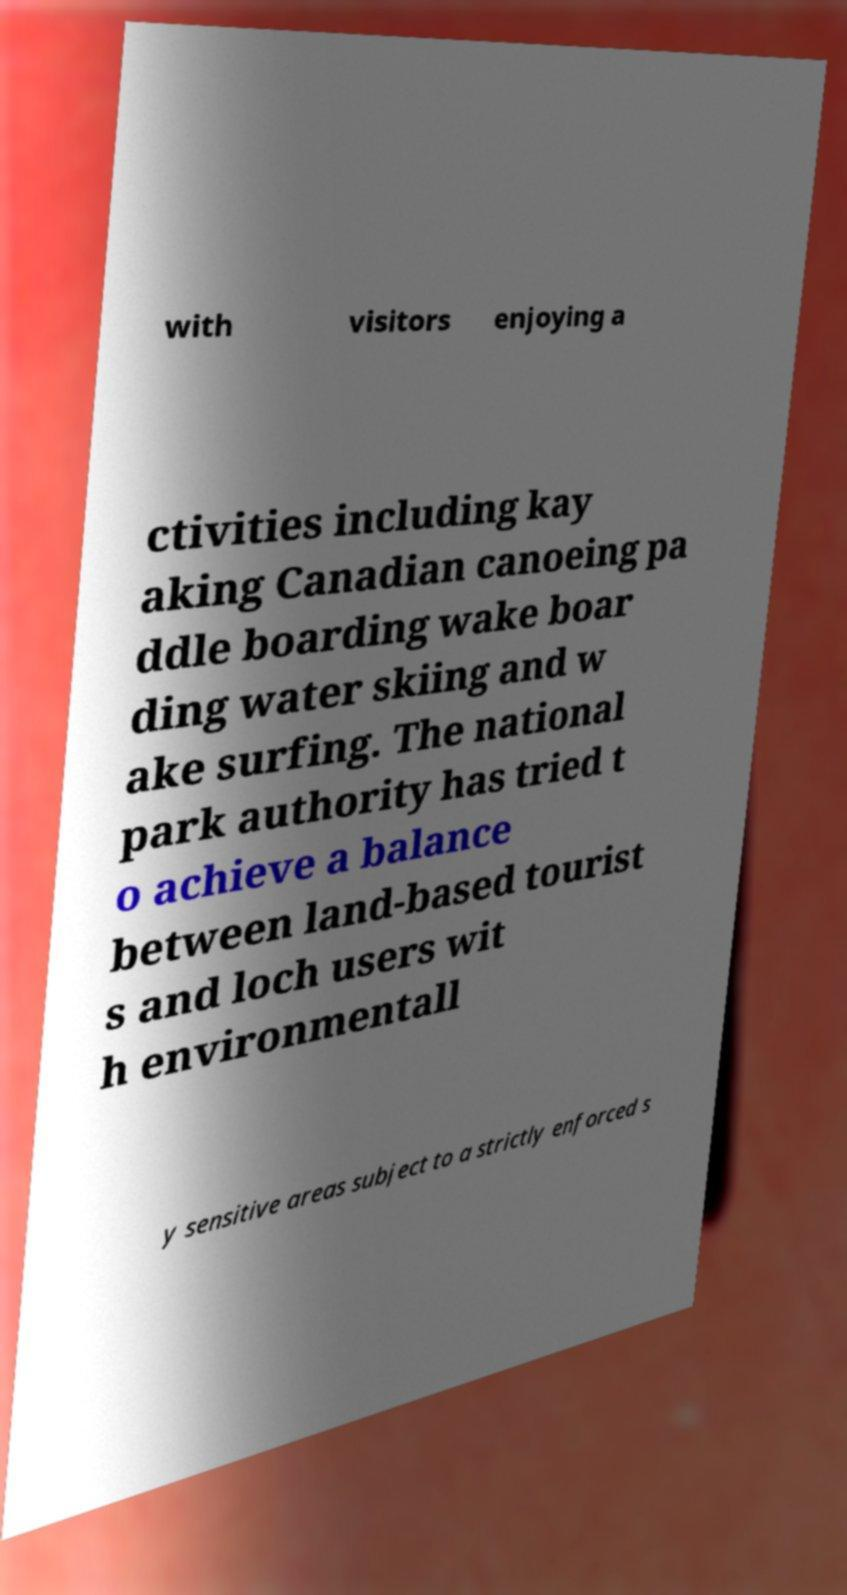Can you accurately transcribe the text from the provided image for me? with visitors enjoying a ctivities including kay aking Canadian canoeing pa ddle boarding wake boar ding water skiing and w ake surfing. The national park authority has tried t o achieve a balance between land-based tourist s and loch users wit h environmentall y sensitive areas subject to a strictly enforced s 